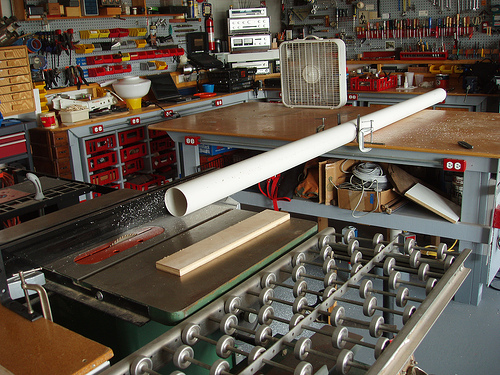<image>
Is there a pipe next to the fan? Yes. The pipe is positioned adjacent to the fan, located nearby in the same general area. 